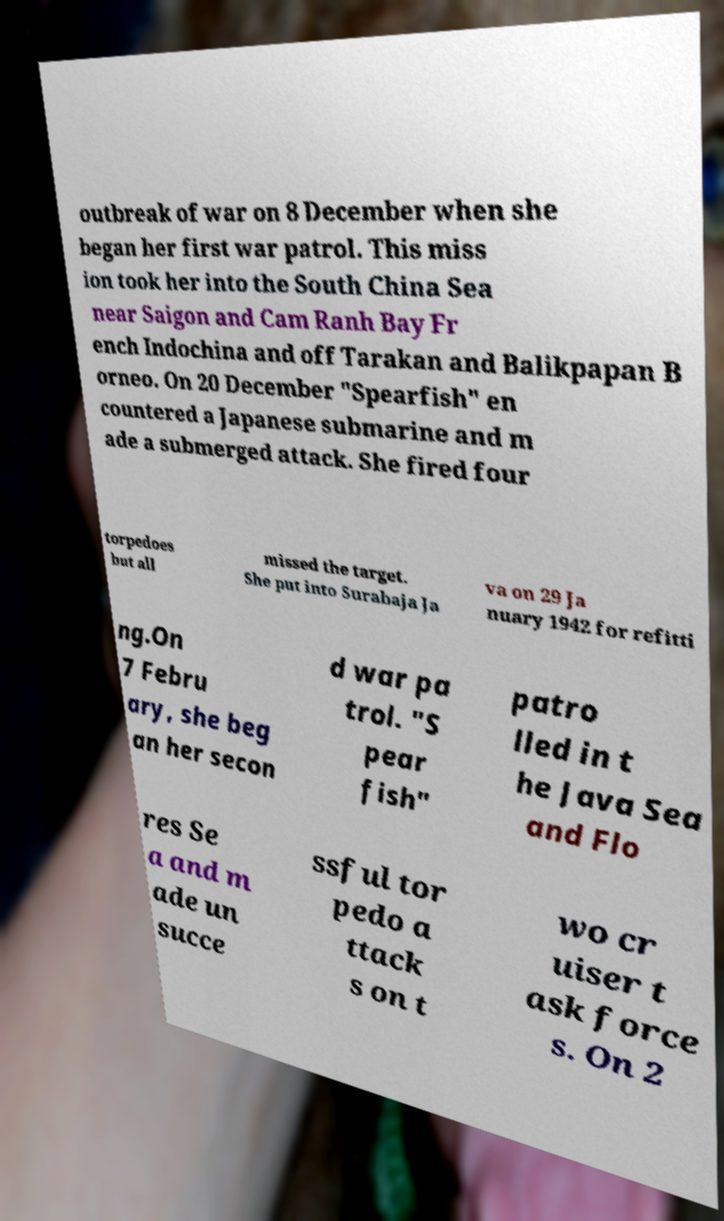I need the written content from this picture converted into text. Can you do that? outbreak of war on 8 December when she began her first war patrol. This miss ion took her into the South China Sea near Saigon and Cam Ranh Bay Fr ench Indochina and off Tarakan and Balikpapan B orneo. On 20 December "Spearfish" en countered a Japanese submarine and m ade a submerged attack. She fired four torpedoes but all missed the target. She put into Surabaja Ja va on 29 Ja nuary 1942 for refitti ng.On 7 Febru ary, she beg an her secon d war pa trol. "S pear fish" patro lled in t he Java Sea and Flo res Se a and m ade un succe ssful tor pedo a ttack s on t wo cr uiser t ask force s. On 2 